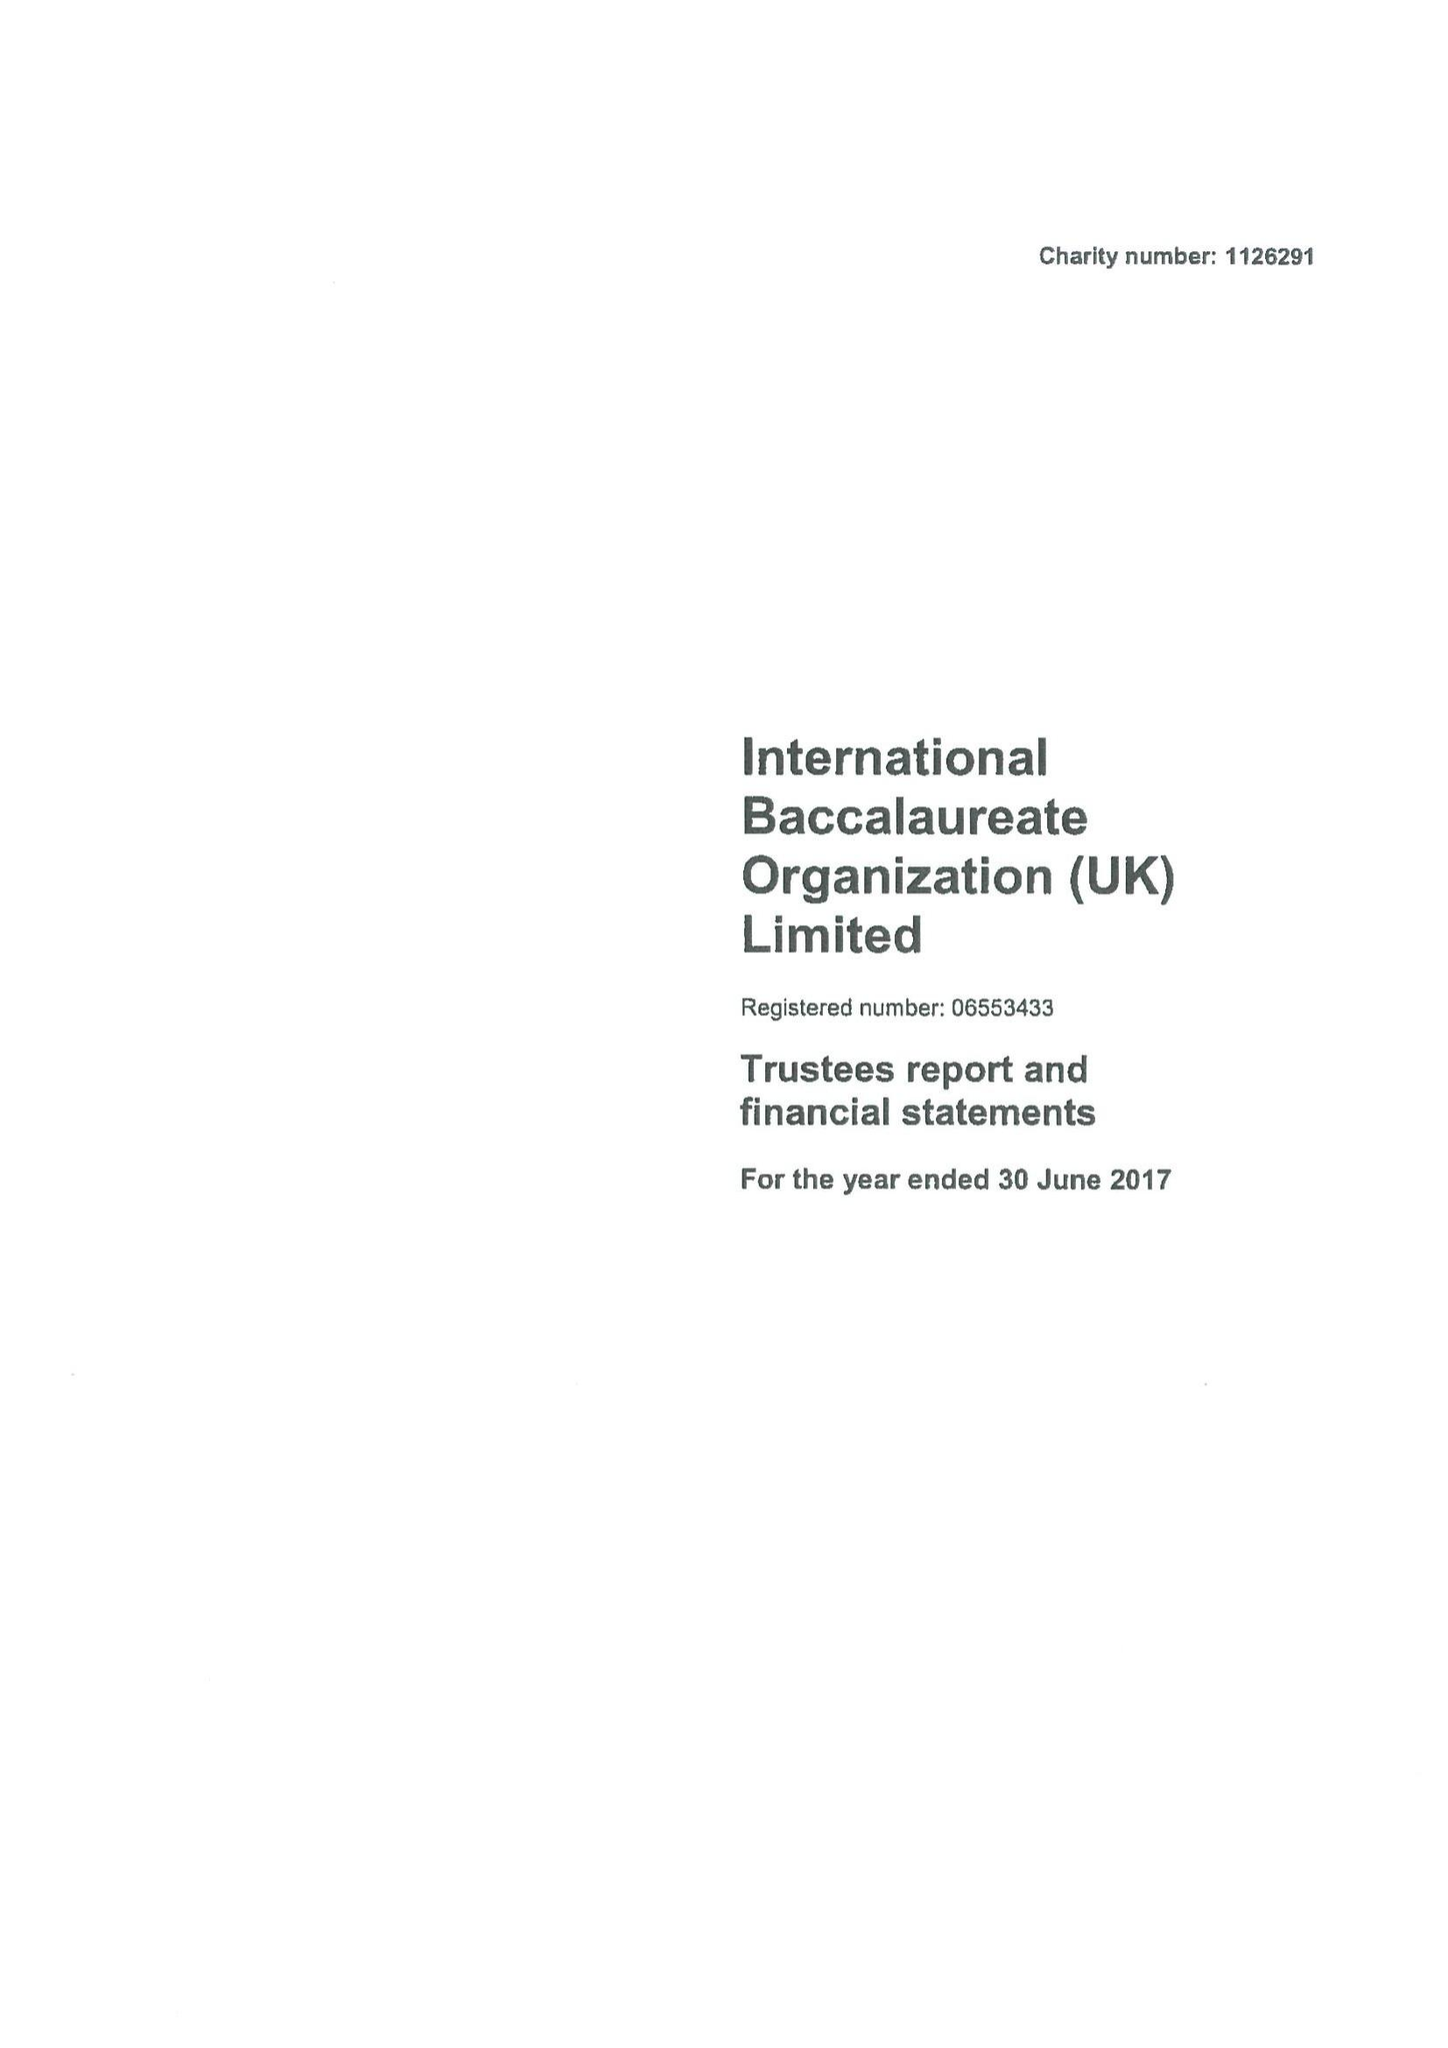What is the value for the address__postcode?
Answer the question using a single word or phrase. None 